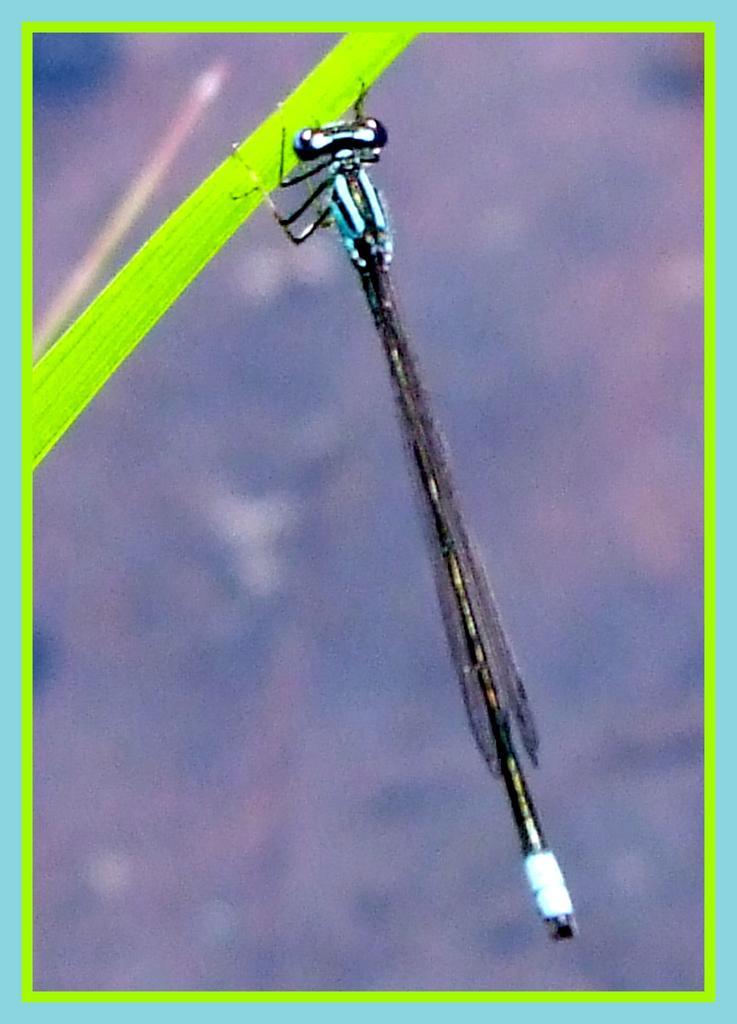In one or two sentences, can you explain what this image depicts? In this image I can see the image is an edited one with the borders blue and green. And there is an insect on the leaf and the background is blurred 